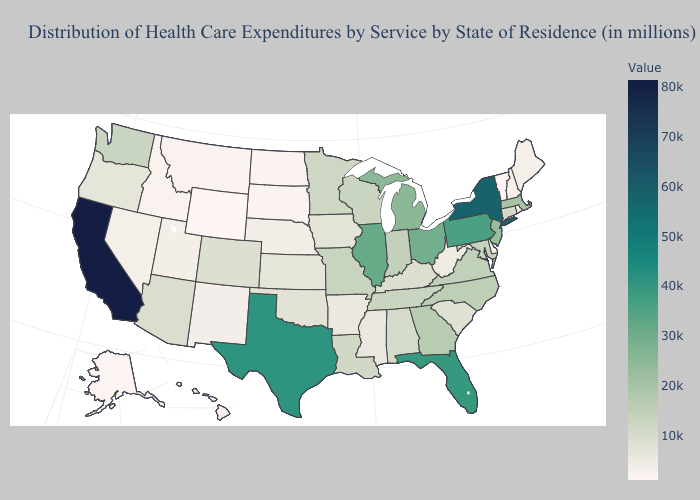Which states have the lowest value in the USA?
Keep it brief. Wyoming. Which states have the lowest value in the Northeast?
Be succinct. Vermont. Among the states that border Colorado , does Kansas have the lowest value?
Concise answer only. No. Does Utah have the lowest value in the USA?
Give a very brief answer. No. Among the states that border Missouri , which have the highest value?
Write a very short answer. Illinois. Among the states that border Idaho , does Washington have the highest value?
Answer briefly. Yes. Which states have the highest value in the USA?
Answer briefly. California. Is the legend a continuous bar?
Write a very short answer. Yes. Does Minnesota have the lowest value in the USA?
Be succinct. No. Does California have the highest value in the West?
Short answer required. Yes. Is the legend a continuous bar?
Write a very short answer. Yes. 